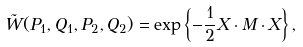Convert formula to latex. <formula><loc_0><loc_0><loc_500><loc_500>\tilde { W } ( P _ { 1 } , Q _ { 1 } , P _ { 2 } , Q _ { 2 } ) = \exp \left \{ - \frac { 1 } { 2 } X \cdot M \cdot X \right \} ,</formula> 